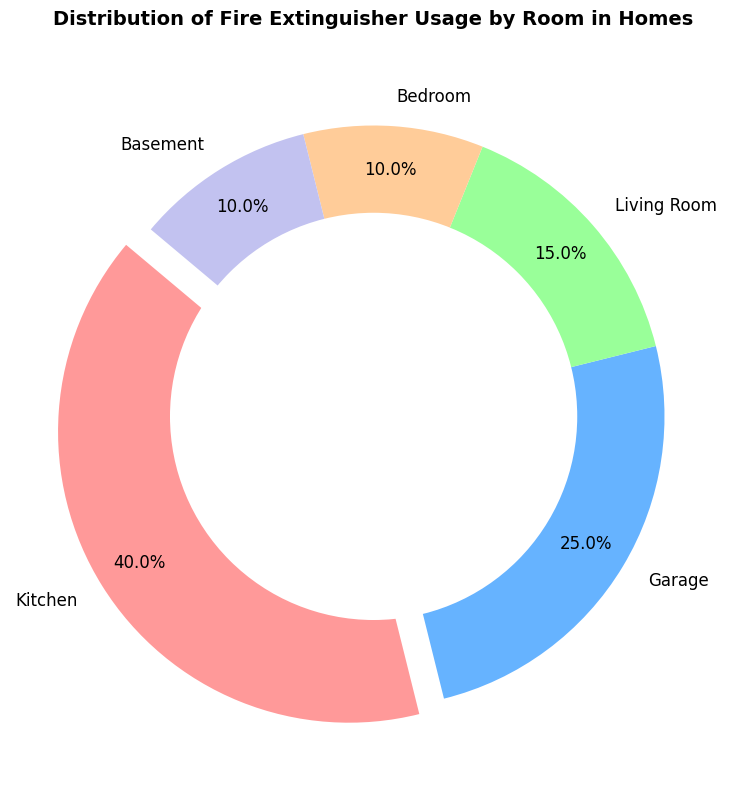What percentage of fire extinguisher usage occurs in the kitchen? The pie chart shows the distribution of fire extinguisher usage by room. The segment labeled "Kitchen" accounts for 40% of the total usage.
Answer: 40% Which room has the highest fire extinguisher usage? By looking at the pie chart, we can see that the Kitchen segment is the largest, and it shows 40% usage, which is the highest among all rooms.
Answer: Kitchen What is the combined percentage of fire extinguisher usage in the Bedroom and Basement? The pie chart indicates that both the Bedroom and Basement each account for 10% of the fire extinguisher usage. Adding these percentages together, we get 10% + 10% = 20%.
Answer: 20% Is fire extinguisher usage in the Garage greater than in the Living Room? According to the pie chart, the Garage has a usage percentage of 25%, whereas the Living Room shows 15%. Since 25% is greater than 15%, fire extinguisher usage in the Garage is indeed greater than in the Living Room.
Answer: Yes Which segments of the pie chart have equal fire extinguisher usage? The pie chart shows that both the Bedroom and Basement segments account for 10% each. Therefore, these two segments have equal fire extinguisher usage.
Answer: Bedroom and Basement How much more fire extinguisher usage is there in the Kitchen compared to the Bedroom? The pie chart indicates a 40% usage in the Kitchen and a 10% usage in the Bedroom. Subtracting these values gives us 40% - 10% = 30%.
Answer: 30% What color is used to represent the Kitchen in the pie chart? Observing the pie chart, the segment labeled "Kitchen" is highlighted in a red color.
Answer: Red If you combine the fire extinguisher usage for the Kitchen, Garage, and Living Room, what percentage of the total do they represent? The pie chart shows that the Kitchen accounts for 40%, the Garage for 25%, and the Living Room for 15%. Adding these percentages together, we get 40% + 25% + 15% = 80%.
Answer: 80% What is the difference in fire extinguisher usage percentage between the room with the highest and the room with the lowest usage? From the pie chart, the Kitchen has the highest usage at 40%, while both the Bedroom and Basement have the lowest at 10%. The difference is 40% - 10% = 30%.
Answer: 30% Is the fire extinguisher usage in the Kitchen more than double the usage in the Living Room? The pie chart shows the Kitchen usage at 40% and the Living Room at 15%. Doubling the Living Room's usage gives us 2 * 15% = 30%, which is still less than the Kitchen's 40%. Therefore, the Kitchen usage is more than double the Living Room usage.
Answer: Yes 